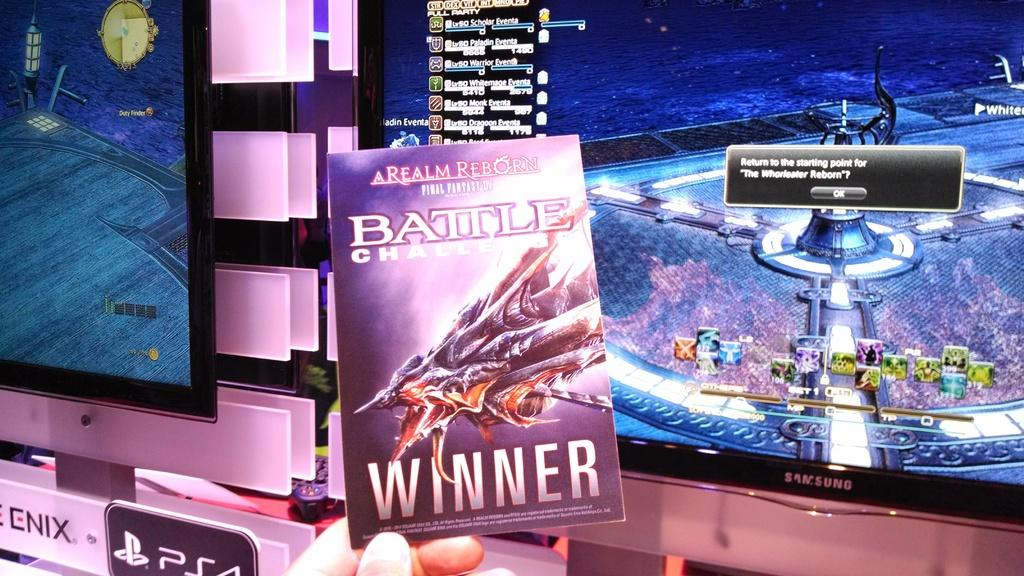Provide a one-sentence caption for the provided image. Samsung screens showing scifi games stand beind this science fiction book entitled A Realm Reborn. 